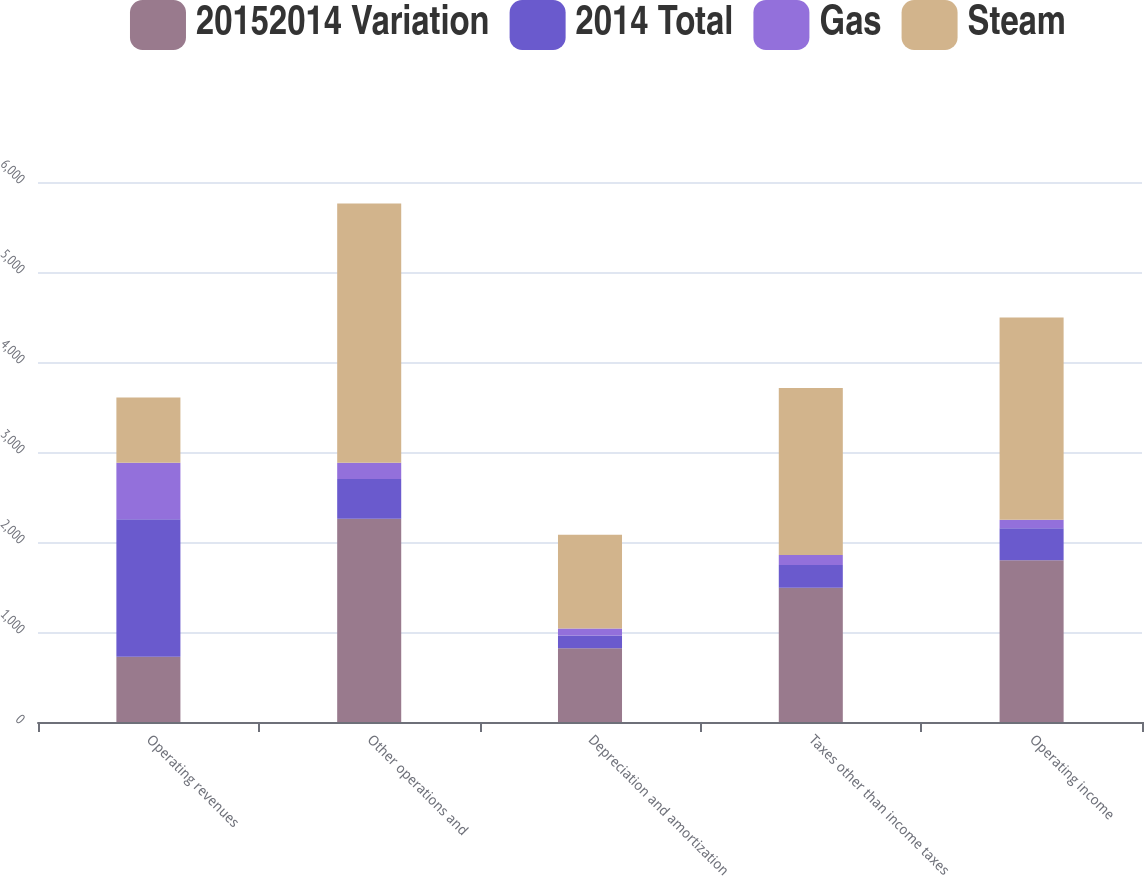Convert chart. <chart><loc_0><loc_0><loc_500><loc_500><stacked_bar_chart><ecel><fcel>Operating revenues<fcel>Other operations and<fcel>Depreciation and amortization<fcel>Taxes other than income taxes<fcel>Operating income<nl><fcel>20152014 Variation<fcel>724.5<fcel>2259<fcel>820<fcel>1493<fcel>1798<nl><fcel>2014 Total<fcel>1527<fcel>440<fcel>142<fcel>252<fcel>356<nl><fcel>Gas<fcel>629<fcel>182<fcel>78<fcel>111<fcel>93<nl><fcel>Steam<fcel>724.5<fcel>2881<fcel>1040<fcel>1856<fcel>2247<nl></chart> 